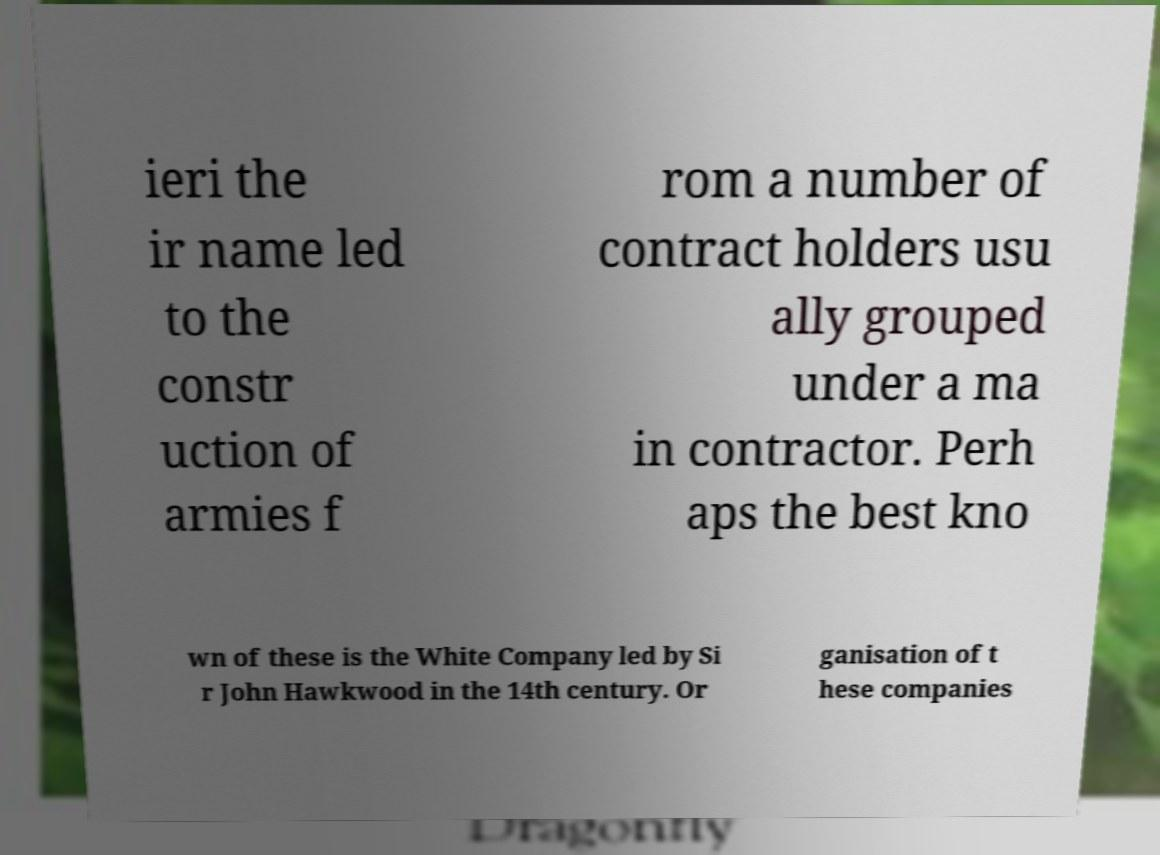I need the written content from this picture converted into text. Can you do that? ieri the ir name led to the constr uction of armies f rom a number of contract holders usu ally grouped under a ma in contractor. Perh aps the best kno wn of these is the White Company led by Si r John Hawkwood in the 14th century. Or ganisation of t hese companies 